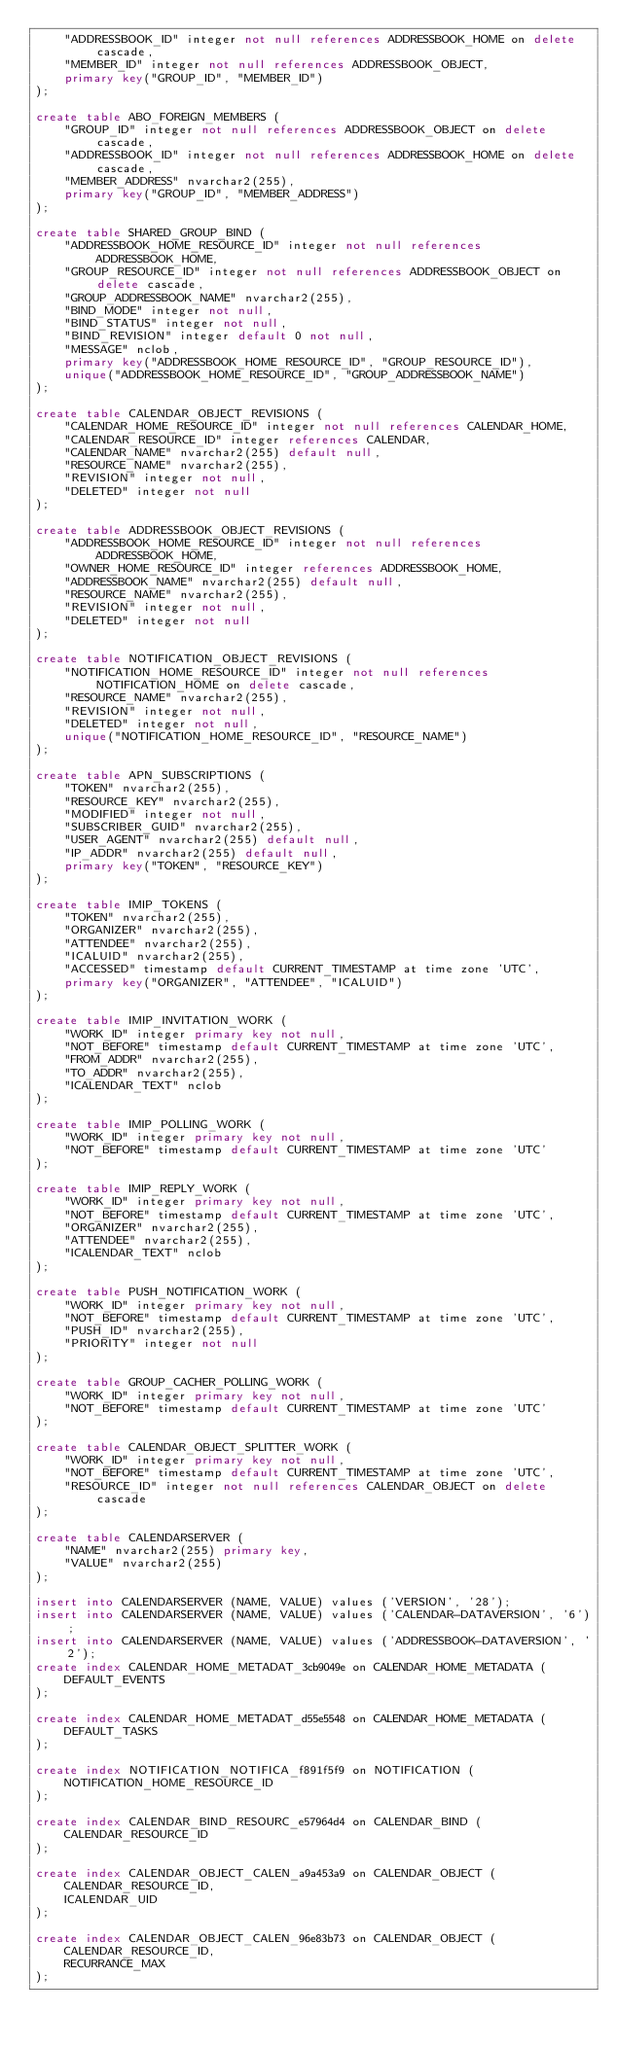Convert code to text. <code><loc_0><loc_0><loc_500><loc_500><_SQL_>    "ADDRESSBOOK_ID" integer not null references ADDRESSBOOK_HOME on delete cascade,
    "MEMBER_ID" integer not null references ADDRESSBOOK_OBJECT, 
    primary key("GROUP_ID", "MEMBER_ID")
);

create table ABO_FOREIGN_MEMBERS (
    "GROUP_ID" integer not null references ADDRESSBOOK_OBJECT on delete cascade,
    "ADDRESSBOOK_ID" integer not null references ADDRESSBOOK_HOME on delete cascade,
    "MEMBER_ADDRESS" nvarchar2(255), 
    primary key("GROUP_ID", "MEMBER_ADDRESS")
);

create table SHARED_GROUP_BIND (
    "ADDRESSBOOK_HOME_RESOURCE_ID" integer not null references ADDRESSBOOK_HOME,
    "GROUP_RESOURCE_ID" integer not null references ADDRESSBOOK_OBJECT on delete cascade,
    "GROUP_ADDRESSBOOK_NAME" nvarchar2(255),
    "BIND_MODE" integer not null,
    "BIND_STATUS" integer not null,
    "BIND_REVISION" integer default 0 not null,
    "MESSAGE" nclob, 
    primary key("ADDRESSBOOK_HOME_RESOURCE_ID", "GROUP_RESOURCE_ID"), 
    unique("ADDRESSBOOK_HOME_RESOURCE_ID", "GROUP_ADDRESSBOOK_NAME")
);

create table CALENDAR_OBJECT_REVISIONS (
    "CALENDAR_HOME_RESOURCE_ID" integer not null references CALENDAR_HOME,
    "CALENDAR_RESOURCE_ID" integer references CALENDAR,
    "CALENDAR_NAME" nvarchar2(255) default null,
    "RESOURCE_NAME" nvarchar2(255),
    "REVISION" integer not null,
    "DELETED" integer not null
);

create table ADDRESSBOOK_OBJECT_REVISIONS (
    "ADDRESSBOOK_HOME_RESOURCE_ID" integer not null references ADDRESSBOOK_HOME,
    "OWNER_HOME_RESOURCE_ID" integer references ADDRESSBOOK_HOME,
    "ADDRESSBOOK_NAME" nvarchar2(255) default null,
    "RESOURCE_NAME" nvarchar2(255),
    "REVISION" integer not null,
    "DELETED" integer not null
);

create table NOTIFICATION_OBJECT_REVISIONS (
    "NOTIFICATION_HOME_RESOURCE_ID" integer not null references NOTIFICATION_HOME on delete cascade,
    "RESOURCE_NAME" nvarchar2(255),
    "REVISION" integer not null,
    "DELETED" integer not null, 
    unique("NOTIFICATION_HOME_RESOURCE_ID", "RESOURCE_NAME")
);

create table APN_SUBSCRIPTIONS (
    "TOKEN" nvarchar2(255),
    "RESOURCE_KEY" nvarchar2(255),
    "MODIFIED" integer not null,
    "SUBSCRIBER_GUID" nvarchar2(255),
    "USER_AGENT" nvarchar2(255) default null,
    "IP_ADDR" nvarchar2(255) default null, 
    primary key("TOKEN", "RESOURCE_KEY")
);

create table IMIP_TOKENS (
    "TOKEN" nvarchar2(255),
    "ORGANIZER" nvarchar2(255),
    "ATTENDEE" nvarchar2(255),
    "ICALUID" nvarchar2(255),
    "ACCESSED" timestamp default CURRENT_TIMESTAMP at time zone 'UTC', 
    primary key("ORGANIZER", "ATTENDEE", "ICALUID")
);

create table IMIP_INVITATION_WORK (
    "WORK_ID" integer primary key not null,
    "NOT_BEFORE" timestamp default CURRENT_TIMESTAMP at time zone 'UTC',
    "FROM_ADDR" nvarchar2(255),
    "TO_ADDR" nvarchar2(255),
    "ICALENDAR_TEXT" nclob
);

create table IMIP_POLLING_WORK (
    "WORK_ID" integer primary key not null,
    "NOT_BEFORE" timestamp default CURRENT_TIMESTAMP at time zone 'UTC'
);

create table IMIP_REPLY_WORK (
    "WORK_ID" integer primary key not null,
    "NOT_BEFORE" timestamp default CURRENT_TIMESTAMP at time zone 'UTC',
    "ORGANIZER" nvarchar2(255),
    "ATTENDEE" nvarchar2(255),
    "ICALENDAR_TEXT" nclob
);

create table PUSH_NOTIFICATION_WORK (
    "WORK_ID" integer primary key not null,
    "NOT_BEFORE" timestamp default CURRENT_TIMESTAMP at time zone 'UTC',
    "PUSH_ID" nvarchar2(255),
    "PRIORITY" integer not null
);

create table GROUP_CACHER_POLLING_WORK (
    "WORK_ID" integer primary key not null,
    "NOT_BEFORE" timestamp default CURRENT_TIMESTAMP at time zone 'UTC'
);

create table CALENDAR_OBJECT_SPLITTER_WORK (
    "WORK_ID" integer primary key not null,
    "NOT_BEFORE" timestamp default CURRENT_TIMESTAMP at time zone 'UTC',
    "RESOURCE_ID" integer not null references CALENDAR_OBJECT on delete cascade
);

create table CALENDARSERVER (
    "NAME" nvarchar2(255) primary key,
    "VALUE" nvarchar2(255)
);

insert into CALENDARSERVER (NAME, VALUE) values ('VERSION', '28');
insert into CALENDARSERVER (NAME, VALUE) values ('CALENDAR-DATAVERSION', '6');
insert into CALENDARSERVER (NAME, VALUE) values ('ADDRESSBOOK-DATAVERSION', '2');
create index CALENDAR_HOME_METADAT_3cb9049e on CALENDAR_HOME_METADATA (
    DEFAULT_EVENTS
);

create index CALENDAR_HOME_METADAT_d55e5548 on CALENDAR_HOME_METADATA (
    DEFAULT_TASKS
);

create index NOTIFICATION_NOTIFICA_f891f5f9 on NOTIFICATION (
    NOTIFICATION_HOME_RESOURCE_ID
);

create index CALENDAR_BIND_RESOURC_e57964d4 on CALENDAR_BIND (
    CALENDAR_RESOURCE_ID
);

create index CALENDAR_OBJECT_CALEN_a9a453a9 on CALENDAR_OBJECT (
    CALENDAR_RESOURCE_ID,
    ICALENDAR_UID
);

create index CALENDAR_OBJECT_CALEN_96e83b73 on CALENDAR_OBJECT (
    CALENDAR_RESOURCE_ID,
    RECURRANCE_MAX
);
</code> 